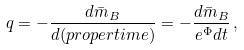Convert formula to latex. <formula><loc_0><loc_0><loc_500><loc_500>q = - \frac { d \bar { m } _ { B } } { d ( p r o p e r t i m e ) } = - \frac { d \bar { m } _ { B } } { e ^ { \Phi } d t } \, ,</formula> 